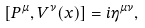Convert formula to latex. <formula><loc_0><loc_0><loc_500><loc_500>[ P ^ { \mu } , V ^ { \nu } ( x ) ] = i \eta ^ { \mu \nu } ,</formula> 